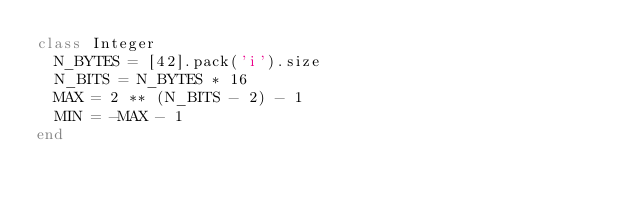Convert code to text. <code><loc_0><loc_0><loc_500><loc_500><_Ruby_>class Integer
  N_BYTES = [42].pack('i').size
  N_BITS = N_BYTES * 16
  MAX = 2 ** (N_BITS - 2) - 1
  MIN = -MAX - 1
end</code> 